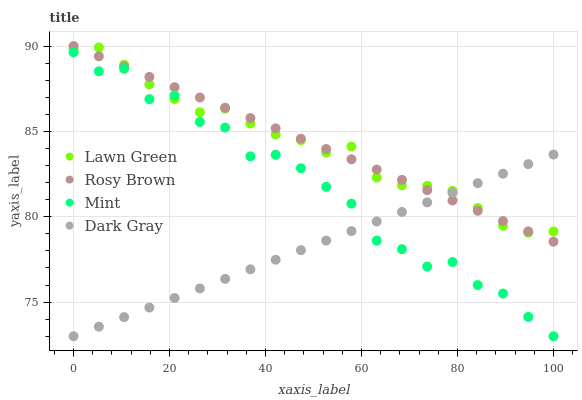Does Dark Gray have the minimum area under the curve?
Answer yes or no. Yes. Does Rosy Brown have the maximum area under the curve?
Answer yes or no. Yes. Does Lawn Green have the minimum area under the curve?
Answer yes or no. No. Does Lawn Green have the maximum area under the curve?
Answer yes or no. No. Is Rosy Brown the smoothest?
Answer yes or no. Yes. Is Mint the roughest?
Answer yes or no. Yes. Is Lawn Green the smoothest?
Answer yes or no. No. Is Lawn Green the roughest?
Answer yes or no. No. Does Dark Gray have the lowest value?
Answer yes or no. Yes. Does Rosy Brown have the lowest value?
Answer yes or no. No. Does Rosy Brown have the highest value?
Answer yes or no. Yes. Does Lawn Green have the highest value?
Answer yes or no. No. Is Mint less than Rosy Brown?
Answer yes or no. Yes. Is Rosy Brown greater than Mint?
Answer yes or no. Yes. Does Lawn Green intersect Dark Gray?
Answer yes or no. Yes. Is Lawn Green less than Dark Gray?
Answer yes or no. No. Is Lawn Green greater than Dark Gray?
Answer yes or no. No. Does Mint intersect Rosy Brown?
Answer yes or no. No. 